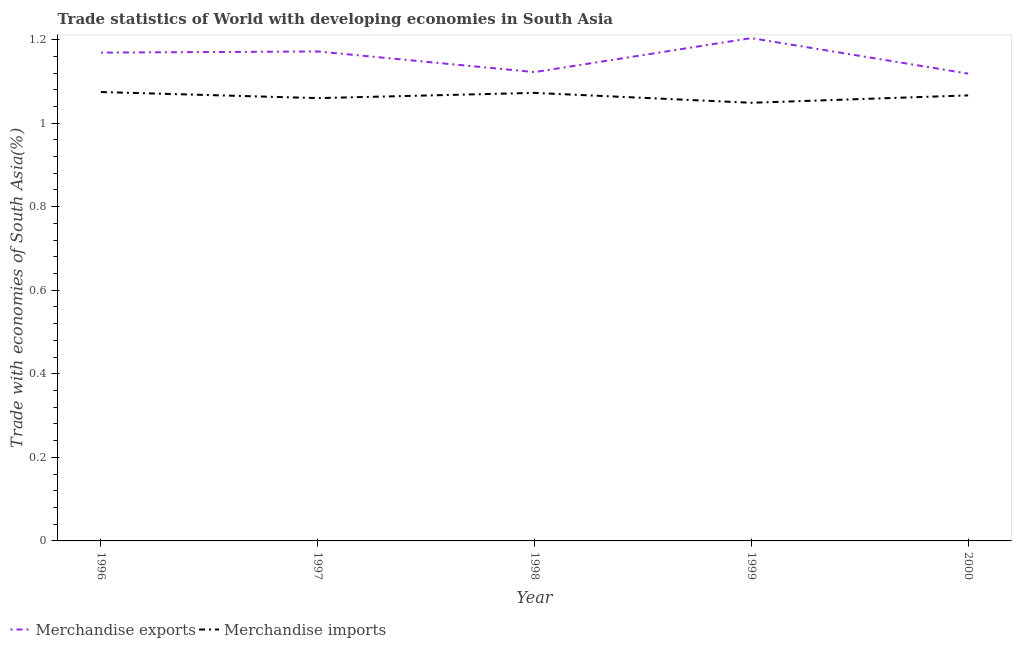Is the number of lines equal to the number of legend labels?
Offer a very short reply. Yes. What is the merchandise exports in 1997?
Make the answer very short. 1.17. Across all years, what is the maximum merchandise exports?
Make the answer very short. 1.2. Across all years, what is the minimum merchandise exports?
Provide a succinct answer. 1.12. In which year was the merchandise exports maximum?
Ensure brevity in your answer.  1999. In which year was the merchandise exports minimum?
Offer a very short reply. 2000. What is the total merchandise imports in the graph?
Offer a very short reply. 5.32. What is the difference between the merchandise exports in 1997 and that in 1998?
Offer a very short reply. 0.05. What is the difference between the merchandise exports in 1999 and the merchandise imports in 2000?
Ensure brevity in your answer.  0.14. What is the average merchandise exports per year?
Ensure brevity in your answer.  1.16. In the year 1996, what is the difference between the merchandise exports and merchandise imports?
Provide a short and direct response. 0.09. In how many years, is the merchandise exports greater than 0.24000000000000002 %?
Offer a very short reply. 5. What is the ratio of the merchandise exports in 1998 to that in 2000?
Provide a succinct answer. 1. Is the merchandise exports in 1997 less than that in 2000?
Provide a succinct answer. No. What is the difference between the highest and the second highest merchandise imports?
Your answer should be compact. 0. What is the difference between the highest and the lowest merchandise exports?
Keep it short and to the point. 0.08. Is the sum of the merchandise imports in 1998 and 2000 greater than the maximum merchandise exports across all years?
Your answer should be very brief. Yes. Does the merchandise exports monotonically increase over the years?
Keep it short and to the point. No. Is the merchandise exports strictly less than the merchandise imports over the years?
Provide a short and direct response. No. How many years are there in the graph?
Your response must be concise. 5. What is the difference between two consecutive major ticks on the Y-axis?
Offer a very short reply. 0.2. Does the graph contain any zero values?
Make the answer very short. No. Does the graph contain grids?
Make the answer very short. No. How many legend labels are there?
Provide a succinct answer. 2. How are the legend labels stacked?
Offer a very short reply. Horizontal. What is the title of the graph?
Your response must be concise. Trade statistics of World with developing economies in South Asia. Does "Exports" appear as one of the legend labels in the graph?
Make the answer very short. No. What is the label or title of the Y-axis?
Provide a succinct answer. Trade with economies of South Asia(%). What is the Trade with economies of South Asia(%) of Merchandise exports in 1996?
Offer a terse response. 1.17. What is the Trade with economies of South Asia(%) of Merchandise imports in 1996?
Provide a succinct answer. 1.07. What is the Trade with economies of South Asia(%) in Merchandise exports in 1997?
Give a very brief answer. 1.17. What is the Trade with economies of South Asia(%) in Merchandise imports in 1997?
Provide a succinct answer. 1.06. What is the Trade with economies of South Asia(%) of Merchandise exports in 1998?
Offer a very short reply. 1.12. What is the Trade with economies of South Asia(%) in Merchandise imports in 1998?
Provide a succinct answer. 1.07. What is the Trade with economies of South Asia(%) of Merchandise exports in 1999?
Your response must be concise. 1.2. What is the Trade with economies of South Asia(%) in Merchandise imports in 1999?
Make the answer very short. 1.05. What is the Trade with economies of South Asia(%) in Merchandise exports in 2000?
Offer a very short reply. 1.12. What is the Trade with economies of South Asia(%) of Merchandise imports in 2000?
Provide a short and direct response. 1.07. Across all years, what is the maximum Trade with economies of South Asia(%) of Merchandise exports?
Your answer should be very brief. 1.2. Across all years, what is the maximum Trade with economies of South Asia(%) in Merchandise imports?
Make the answer very short. 1.07. Across all years, what is the minimum Trade with economies of South Asia(%) in Merchandise exports?
Your response must be concise. 1.12. Across all years, what is the minimum Trade with economies of South Asia(%) of Merchandise imports?
Your answer should be very brief. 1.05. What is the total Trade with economies of South Asia(%) of Merchandise exports in the graph?
Offer a terse response. 5.78. What is the total Trade with economies of South Asia(%) of Merchandise imports in the graph?
Your answer should be compact. 5.32. What is the difference between the Trade with economies of South Asia(%) in Merchandise exports in 1996 and that in 1997?
Ensure brevity in your answer.  -0. What is the difference between the Trade with economies of South Asia(%) of Merchandise imports in 1996 and that in 1997?
Keep it short and to the point. 0.01. What is the difference between the Trade with economies of South Asia(%) in Merchandise exports in 1996 and that in 1998?
Your response must be concise. 0.05. What is the difference between the Trade with economies of South Asia(%) in Merchandise imports in 1996 and that in 1998?
Your answer should be compact. 0. What is the difference between the Trade with economies of South Asia(%) of Merchandise exports in 1996 and that in 1999?
Ensure brevity in your answer.  -0.03. What is the difference between the Trade with economies of South Asia(%) in Merchandise imports in 1996 and that in 1999?
Keep it short and to the point. 0.03. What is the difference between the Trade with economies of South Asia(%) in Merchandise exports in 1996 and that in 2000?
Ensure brevity in your answer.  0.05. What is the difference between the Trade with economies of South Asia(%) in Merchandise imports in 1996 and that in 2000?
Offer a terse response. 0.01. What is the difference between the Trade with economies of South Asia(%) of Merchandise exports in 1997 and that in 1998?
Your response must be concise. 0.05. What is the difference between the Trade with economies of South Asia(%) in Merchandise imports in 1997 and that in 1998?
Your response must be concise. -0.01. What is the difference between the Trade with economies of South Asia(%) in Merchandise exports in 1997 and that in 1999?
Give a very brief answer. -0.03. What is the difference between the Trade with economies of South Asia(%) of Merchandise imports in 1997 and that in 1999?
Offer a terse response. 0.01. What is the difference between the Trade with economies of South Asia(%) of Merchandise exports in 1997 and that in 2000?
Give a very brief answer. 0.05. What is the difference between the Trade with economies of South Asia(%) in Merchandise imports in 1997 and that in 2000?
Provide a succinct answer. -0.01. What is the difference between the Trade with economies of South Asia(%) of Merchandise exports in 1998 and that in 1999?
Provide a short and direct response. -0.08. What is the difference between the Trade with economies of South Asia(%) in Merchandise imports in 1998 and that in 1999?
Offer a terse response. 0.02. What is the difference between the Trade with economies of South Asia(%) of Merchandise exports in 1998 and that in 2000?
Keep it short and to the point. 0. What is the difference between the Trade with economies of South Asia(%) in Merchandise imports in 1998 and that in 2000?
Offer a very short reply. 0.01. What is the difference between the Trade with economies of South Asia(%) in Merchandise exports in 1999 and that in 2000?
Offer a terse response. 0.08. What is the difference between the Trade with economies of South Asia(%) of Merchandise imports in 1999 and that in 2000?
Offer a terse response. -0.02. What is the difference between the Trade with economies of South Asia(%) in Merchandise exports in 1996 and the Trade with economies of South Asia(%) in Merchandise imports in 1997?
Provide a short and direct response. 0.11. What is the difference between the Trade with economies of South Asia(%) of Merchandise exports in 1996 and the Trade with economies of South Asia(%) of Merchandise imports in 1998?
Provide a short and direct response. 0.1. What is the difference between the Trade with economies of South Asia(%) in Merchandise exports in 1996 and the Trade with economies of South Asia(%) in Merchandise imports in 1999?
Ensure brevity in your answer.  0.12. What is the difference between the Trade with economies of South Asia(%) of Merchandise exports in 1996 and the Trade with economies of South Asia(%) of Merchandise imports in 2000?
Give a very brief answer. 0.1. What is the difference between the Trade with economies of South Asia(%) of Merchandise exports in 1997 and the Trade with economies of South Asia(%) of Merchandise imports in 1998?
Provide a short and direct response. 0.1. What is the difference between the Trade with economies of South Asia(%) of Merchandise exports in 1997 and the Trade with economies of South Asia(%) of Merchandise imports in 1999?
Provide a short and direct response. 0.12. What is the difference between the Trade with economies of South Asia(%) of Merchandise exports in 1997 and the Trade with economies of South Asia(%) of Merchandise imports in 2000?
Keep it short and to the point. 0.11. What is the difference between the Trade with economies of South Asia(%) in Merchandise exports in 1998 and the Trade with economies of South Asia(%) in Merchandise imports in 1999?
Give a very brief answer. 0.07. What is the difference between the Trade with economies of South Asia(%) in Merchandise exports in 1998 and the Trade with economies of South Asia(%) in Merchandise imports in 2000?
Make the answer very short. 0.06. What is the difference between the Trade with economies of South Asia(%) in Merchandise exports in 1999 and the Trade with economies of South Asia(%) in Merchandise imports in 2000?
Make the answer very short. 0.14. What is the average Trade with economies of South Asia(%) of Merchandise exports per year?
Give a very brief answer. 1.16. What is the average Trade with economies of South Asia(%) in Merchandise imports per year?
Give a very brief answer. 1.06. In the year 1996, what is the difference between the Trade with economies of South Asia(%) in Merchandise exports and Trade with economies of South Asia(%) in Merchandise imports?
Your response must be concise. 0.09. In the year 1997, what is the difference between the Trade with economies of South Asia(%) of Merchandise exports and Trade with economies of South Asia(%) of Merchandise imports?
Provide a short and direct response. 0.11. In the year 1998, what is the difference between the Trade with economies of South Asia(%) in Merchandise exports and Trade with economies of South Asia(%) in Merchandise imports?
Keep it short and to the point. 0.05. In the year 1999, what is the difference between the Trade with economies of South Asia(%) in Merchandise exports and Trade with economies of South Asia(%) in Merchandise imports?
Offer a terse response. 0.15. In the year 2000, what is the difference between the Trade with economies of South Asia(%) in Merchandise exports and Trade with economies of South Asia(%) in Merchandise imports?
Your answer should be compact. 0.05. What is the ratio of the Trade with economies of South Asia(%) of Merchandise exports in 1996 to that in 1997?
Make the answer very short. 1. What is the ratio of the Trade with economies of South Asia(%) of Merchandise imports in 1996 to that in 1997?
Make the answer very short. 1.01. What is the ratio of the Trade with economies of South Asia(%) of Merchandise exports in 1996 to that in 1998?
Offer a terse response. 1.04. What is the ratio of the Trade with economies of South Asia(%) in Merchandise exports in 1996 to that in 1999?
Provide a short and direct response. 0.97. What is the ratio of the Trade with economies of South Asia(%) of Merchandise imports in 1996 to that in 1999?
Offer a very short reply. 1.02. What is the ratio of the Trade with economies of South Asia(%) of Merchandise exports in 1996 to that in 2000?
Offer a very short reply. 1.04. What is the ratio of the Trade with economies of South Asia(%) in Merchandise imports in 1996 to that in 2000?
Your response must be concise. 1.01. What is the ratio of the Trade with economies of South Asia(%) in Merchandise exports in 1997 to that in 1998?
Your response must be concise. 1.04. What is the ratio of the Trade with economies of South Asia(%) of Merchandise imports in 1997 to that in 1998?
Provide a succinct answer. 0.99. What is the ratio of the Trade with economies of South Asia(%) in Merchandise exports in 1997 to that in 1999?
Make the answer very short. 0.97. What is the ratio of the Trade with economies of South Asia(%) in Merchandise imports in 1997 to that in 1999?
Offer a very short reply. 1.01. What is the ratio of the Trade with economies of South Asia(%) of Merchandise exports in 1997 to that in 2000?
Your response must be concise. 1.05. What is the ratio of the Trade with economies of South Asia(%) of Merchandise imports in 1997 to that in 2000?
Provide a succinct answer. 0.99. What is the ratio of the Trade with economies of South Asia(%) in Merchandise exports in 1998 to that in 1999?
Your answer should be very brief. 0.93. What is the ratio of the Trade with economies of South Asia(%) of Merchandise imports in 1998 to that in 1999?
Keep it short and to the point. 1.02. What is the ratio of the Trade with economies of South Asia(%) of Merchandise exports in 1998 to that in 2000?
Offer a very short reply. 1. What is the ratio of the Trade with economies of South Asia(%) of Merchandise imports in 1998 to that in 2000?
Give a very brief answer. 1.01. What is the ratio of the Trade with economies of South Asia(%) of Merchandise exports in 1999 to that in 2000?
Give a very brief answer. 1.08. What is the ratio of the Trade with economies of South Asia(%) in Merchandise imports in 1999 to that in 2000?
Keep it short and to the point. 0.98. What is the difference between the highest and the second highest Trade with economies of South Asia(%) of Merchandise exports?
Keep it short and to the point. 0.03. What is the difference between the highest and the second highest Trade with economies of South Asia(%) in Merchandise imports?
Provide a succinct answer. 0. What is the difference between the highest and the lowest Trade with economies of South Asia(%) of Merchandise exports?
Ensure brevity in your answer.  0.08. What is the difference between the highest and the lowest Trade with economies of South Asia(%) in Merchandise imports?
Ensure brevity in your answer.  0.03. 